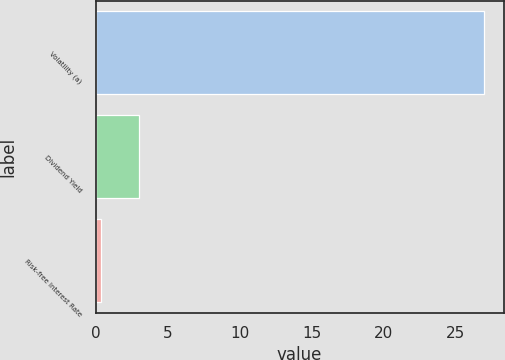Convert chart. <chart><loc_0><loc_0><loc_500><loc_500><bar_chart><fcel>Volatility (a)<fcel>Dividend Yield<fcel>Risk-free Interest Rate<nl><fcel>27<fcel>3.04<fcel>0.38<nl></chart> 